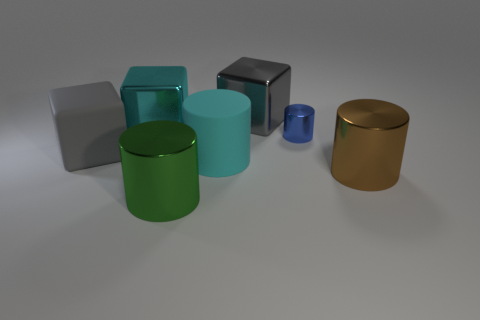The large metal thing that is left of the large cyan matte cylinder and behind the big brown cylinder has what shape?
Your answer should be very brief. Cube. Do the shiny cylinder that is to the left of the gray metallic block and the big matte cylinder have the same color?
Make the answer very short. No. Do the big metal object behind the cyan shiny object and the gray object in front of the tiny metal cylinder have the same shape?
Offer a very short reply. Yes. How big is the block that is in front of the blue metal cylinder?
Provide a succinct answer. Large. What is the size of the metallic cylinder behind the large matte object left of the green metal thing?
Ensure brevity in your answer.  Small. Is the number of cyan rubber cylinders greater than the number of big metallic blocks?
Keep it short and to the point. No. Are there more cylinders left of the tiny blue metallic cylinder than big green metallic cylinders behind the large cyan cylinder?
Offer a terse response. Yes. What is the size of the metallic cylinder that is in front of the big gray rubber thing and on the right side of the big gray metallic block?
Ensure brevity in your answer.  Large. How many blue objects have the same size as the brown shiny cylinder?
Make the answer very short. 0. There is a large gray thing that is right of the green cylinder; is its shape the same as the cyan shiny thing?
Offer a very short reply. Yes. 